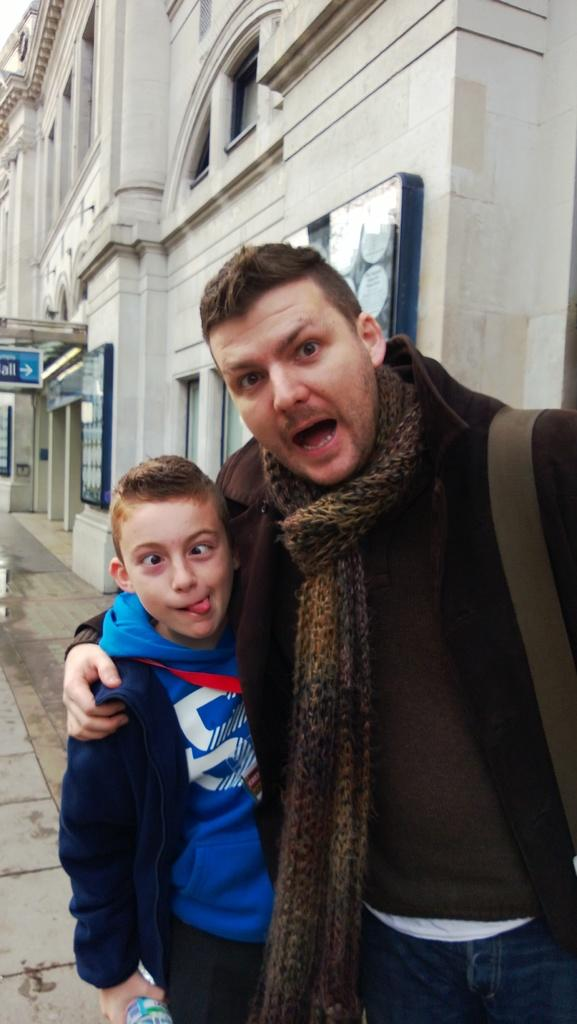How many people are in the image? There are two people in the image. What are the people doing in the image? The people are standing on a footpath. What are the people wearing in the image? The people are wearing jackets. What can be seen in the background of the image? There is a building visible in the background of the image. What type of soda is the person holding in the image? There is no soda present in the image; the people are wearing jackets and standing on a footpath. 